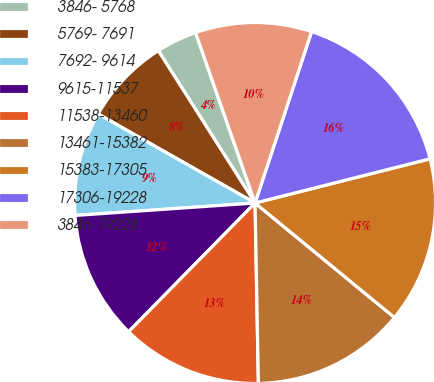Convert chart. <chart><loc_0><loc_0><loc_500><loc_500><pie_chart><fcel>3846- 5768<fcel>5769- 7691<fcel>7692- 9614<fcel>9615-11537<fcel>11538-13460<fcel>13461-15382<fcel>15383-17305<fcel>17306-19228<fcel>3846-19228<nl><fcel>3.66%<fcel>7.78%<fcel>9.31%<fcel>11.54%<fcel>12.65%<fcel>13.76%<fcel>14.88%<fcel>15.99%<fcel>10.42%<nl></chart> 